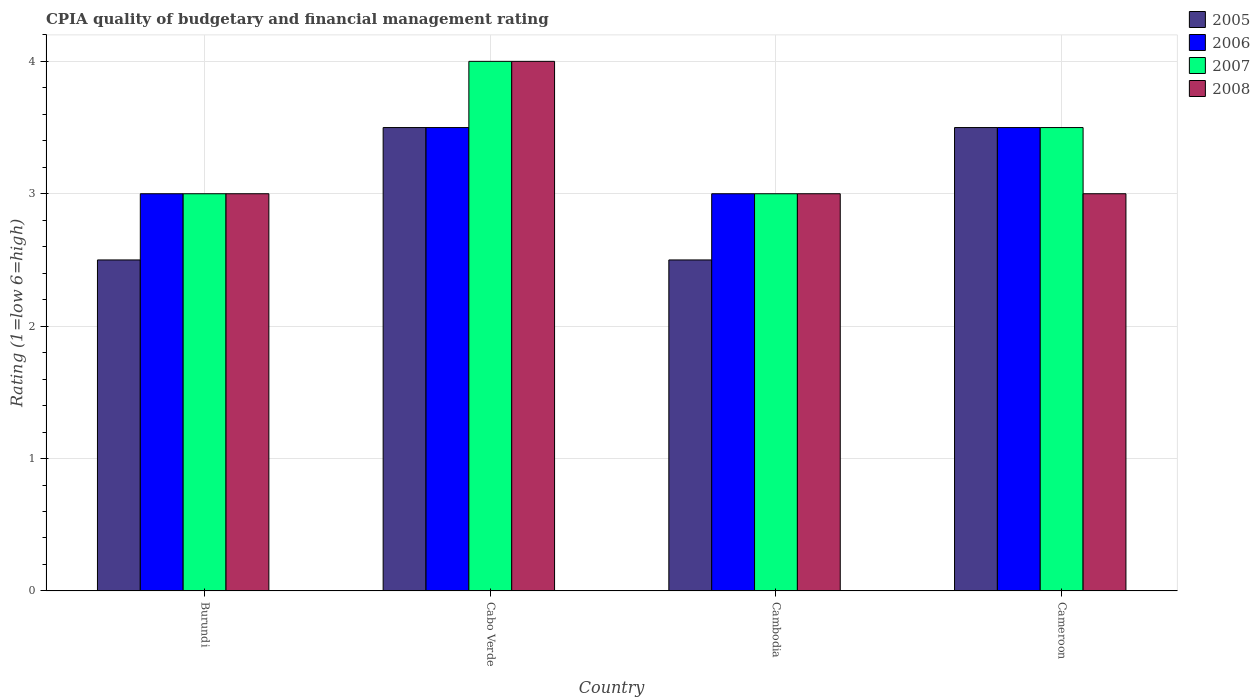How many different coloured bars are there?
Make the answer very short. 4. How many bars are there on the 1st tick from the right?
Ensure brevity in your answer.  4. What is the label of the 2nd group of bars from the left?
Offer a terse response. Cabo Verde. Across all countries, what is the minimum CPIA rating in 2008?
Provide a succinct answer. 3. In which country was the CPIA rating in 2008 maximum?
Keep it short and to the point. Cabo Verde. In which country was the CPIA rating in 2008 minimum?
Keep it short and to the point. Burundi. What is the difference between the CPIA rating in 2007 in Cabo Verde and that in Cameroon?
Your response must be concise. 0.5. What is the difference between the CPIA rating of/in 2006 and CPIA rating of/in 2008 in Cambodia?
Keep it short and to the point. 0. What is the ratio of the CPIA rating in 2006 in Cambodia to that in Cameroon?
Offer a terse response. 0.86. What is the difference between the highest and the second highest CPIA rating in 2005?
Make the answer very short. -1. Is it the case that in every country, the sum of the CPIA rating in 2008 and CPIA rating in 2007 is greater than the sum of CPIA rating in 2006 and CPIA rating in 2005?
Keep it short and to the point. No. Is it the case that in every country, the sum of the CPIA rating in 2007 and CPIA rating in 2006 is greater than the CPIA rating in 2008?
Keep it short and to the point. Yes. How many bars are there?
Your response must be concise. 16. Are all the bars in the graph horizontal?
Your answer should be very brief. No. How many countries are there in the graph?
Provide a short and direct response. 4. What is the difference between two consecutive major ticks on the Y-axis?
Your answer should be compact. 1. Does the graph contain grids?
Make the answer very short. Yes. How many legend labels are there?
Your response must be concise. 4. How are the legend labels stacked?
Make the answer very short. Vertical. What is the title of the graph?
Your response must be concise. CPIA quality of budgetary and financial management rating. What is the Rating (1=low 6=high) of 2006 in Burundi?
Offer a very short reply. 3. What is the Rating (1=low 6=high) of 2005 in Cabo Verde?
Your answer should be compact. 3.5. What is the Rating (1=low 6=high) in 2006 in Cabo Verde?
Make the answer very short. 3.5. What is the Rating (1=low 6=high) in 2008 in Cabo Verde?
Offer a terse response. 4. What is the Rating (1=low 6=high) of 2006 in Cambodia?
Provide a short and direct response. 3. What is the Rating (1=low 6=high) in 2006 in Cameroon?
Provide a succinct answer. 3.5. What is the Rating (1=low 6=high) of 2007 in Cameroon?
Your answer should be compact. 3.5. What is the Rating (1=low 6=high) in 2008 in Cameroon?
Your answer should be very brief. 3. Across all countries, what is the maximum Rating (1=low 6=high) in 2006?
Give a very brief answer. 3.5. Across all countries, what is the maximum Rating (1=low 6=high) of 2007?
Give a very brief answer. 4. Across all countries, what is the maximum Rating (1=low 6=high) in 2008?
Provide a succinct answer. 4. Across all countries, what is the minimum Rating (1=low 6=high) in 2005?
Keep it short and to the point. 2.5. Across all countries, what is the minimum Rating (1=low 6=high) of 2007?
Provide a succinct answer. 3. Across all countries, what is the minimum Rating (1=low 6=high) of 2008?
Give a very brief answer. 3. What is the total Rating (1=low 6=high) in 2005 in the graph?
Your response must be concise. 12. What is the total Rating (1=low 6=high) of 2008 in the graph?
Your answer should be compact. 13. What is the difference between the Rating (1=low 6=high) of 2005 in Burundi and that in Cabo Verde?
Provide a short and direct response. -1. What is the difference between the Rating (1=low 6=high) in 2006 in Burundi and that in Cabo Verde?
Your answer should be very brief. -0.5. What is the difference between the Rating (1=low 6=high) of 2006 in Burundi and that in Cambodia?
Provide a succinct answer. 0. What is the difference between the Rating (1=low 6=high) of 2007 in Burundi and that in Cambodia?
Your answer should be compact. 0. What is the difference between the Rating (1=low 6=high) in 2005 in Burundi and that in Cameroon?
Your response must be concise. -1. What is the difference between the Rating (1=low 6=high) of 2006 in Burundi and that in Cameroon?
Your answer should be very brief. -0.5. What is the difference between the Rating (1=low 6=high) of 2008 in Burundi and that in Cameroon?
Your answer should be very brief. 0. What is the difference between the Rating (1=low 6=high) in 2007 in Cabo Verde and that in Cambodia?
Give a very brief answer. 1. What is the difference between the Rating (1=low 6=high) in 2008 in Cabo Verde and that in Cambodia?
Keep it short and to the point. 1. What is the difference between the Rating (1=low 6=high) of 2007 in Cabo Verde and that in Cameroon?
Offer a very short reply. 0.5. What is the difference between the Rating (1=low 6=high) in 2008 in Cabo Verde and that in Cameroon?
Your answer should be compact. 1. What is the difference between the Rating (1=low 6=high) in 2005 in Cambodia and that in Cameroon?
Your response must be concise. -1. What is the difference between the Rating (1=low 6=high) in 2006 in Cambodia and that in Cameroon?
Give a very brief answer. -0.5. What is the difference between the Rating (1=low 6=high) in 2008 in Cambodia and that in Cameroon?
Your response must be concise. 0. What is the difference between the Rating (1=low 6=high) of 2005 in Burundi and the Rating (1=low 6=high) of 2008 in Cabo Verde?
Provide a succinct answer. -1.5. What is the difference between the Rating (1=low 6=high) in 2007 in Burundi and the Rating (1=low 6=high) in 2008 in Cabo Verde?
Keep it short and to the point. -1. What is the difference between the Rating (1=low 6=high) of 2005 in Burundi and the Rating (1=low 6=high) of 2008 in Cambodia?
Your response must be concise. -0.5. What is the difference between the Rating (1=low 6=high) in 2006 in Burundi and the Rating (1=low 6=high) in 2007 in Cambodia?
Make the answer very short. 0. What is the difference between the Rating (1=low 6=high) of 2007 in Burundi and the Rating (1=low 6=high) of 2008 in Cambodia?
Your answer should be compact. 0. What is the difference between the Rating (1=low 6=high) of 2005 in Burundi and the Rating (1=low 6=high) of 2006 in Cameroon?
Keep it short and to the point. -1. What is the difference between the Rating (1=low 6=high) in 2005 in Burundi and the Rating (1=low 6=high) in 2008 in Cameroon?
Keep it short and to the point. -0.5. What is the difference between the Rating (1=low 6=high) of 2006 in Burundi and the Rating (1=low 6=high) of 2007 in Cameroon?
Provide a succinct answer. -0.5. What is the difference between the Rating (1=low 6=high) in 2006 in Cabo Verde and the Rating (1=low 6=high) in 2007 in Cambodia?
Make the answer very short. 0.5. What is the difference between the Rating (1=low 6=high) in 2005 in Cabo Verde and the Rating (1=low 6=high) in 2006 in Cameroon?
Offer a terse response. 0. What is the difference between the Rating (1=low 6=high) of 2005 in Cabo Verde and the Rating (1=low 6=high) of 2008 in Cameroon?
Offer a very short reply. 0.5. What is the difference between the Rating (1=low 6=high) in 2006 in Cabo Verde and the Rating (1=low 6=high) in 2007 in Cameroon?
Give a very brief answer. 0. What is the difference between the Rating (1=low 6=high) of 2006 in Cabo Verde and the Rating (1=low 6=high) of 2008 in Cameroon?
Offer a terse response. 0.5. What is the difference between the Rating (1=low 6=high) of 2005 in Cambodia and the Rating (1=low 6=high) of 2006 in Cameroon?
Give a very brief answer. -1. What is the difference between the Rating (1=low 6=high) in 2005 in Cambodia and the Rating (1=low 6=high) in 2008 in Cameroon?
Offer a terse response. -0.5. What is the difference between the Rating (1=low 6=high) in 2006 in Cambodia and the Rating (1=low 6=high) in 2007 in Cameroon?
Ensure brevity in your answer.  -0.5. What is the average Rating (1=low 6=high) in 2005 per country?
Your response must be concise. 3. What is the average Rating (1=low 6=high) in 2007 per country?
Keep it short and to the point. 3.38. What is the difference between the Rating (1=low 6=high) in 2005 and Rating (1=low 6=high) in 2006 in Burundi?
Keep it short and to the point. -0.5. What is the difference between the Rating (1=low 6=high) of 2005 and Rating (1=low 6=high) of 2007 in Burundi?
Keep it short and to the point. -0.5. What is the difference between the Rating (1=low 6=high) of 2005 and Rating (1=low 6=high) of 2008 in Burundi?
Your answer should be very brief. -0.5. What is the difference between the Rating (1=low 6=high) of 2006 and Rating (1=low 6=high) of 2007 in Burundi?
Keep it short and to the point. 0. What is the difference between the Rating (1=low 6=high) in 2006 and Rating (1=low 6=high) in 2008 in Burundi?
Provide a short and direct response. 0. What is the difference between the Rating (1=low 6=high) of 2007 and Rating (1=low 6=high) of 2008 in Burundi?
Give a very brief answer. 0. What is the difference between the Rating (1=low 6=high) in 2005 and Rating (1=low 6=high) in 2007 in Cabo Verde?
Give a very brief answer. -0.5. What is the difference between the Rating (1=low 6=high) in 2005 and Rating (1=low 6=high) in 2007 in Cambodia?
Give a very brief answer. -0.5. What is the difference between the Rating (1=low 6=high) in 2007 and Rating (1=low 6=high) in 2008 in Cambodia?
Give a very brief answer. 0. What is the difference between the Rating (1=low 6=high) of 2005 and Rating (1=low 6=high) of 2007 in Cameroon?
Your answer should be very brief. 0. What is the difference between the Rating (1=low 6=high) of 2005 and Rating (1=low 6=high) of 2008 in Cameroon?
Make the answer very short. 0.5. What is the difference between the Rating (1=low 6=high) of 2006 and Rating (1=low 6=high) of 2008 in Cameroon?
Offer a terse response. 0.5. What is the difference between the Rating (1=low 6=high) of 2007 and Rating (1=low 6=high) of 2008 in Cameroon?
Your answer should be very brief. 0.5. What is the ratio of the Rating (1=low 6=high) in 2008 in Burundi to that in Cabo Verde?
Provide a short and direct response. 0.75. What is the ratio of the Rating (1=low 6=high) of 2005 in Burundi to that in Cambodia?
Your response must be concise. 1. What is the ratio of the Rating (1=low 6=high) of 2006 in Burundi to that in Cambodia?
Offer a terse response. 1. What is the ratio of the Rating (1=low 6=high) in 2005 in Burundi to that in Cameroon?
Ensure brevity in your answer.  0.71. What is the ratio of the Rating (1=low 6=high) of 2005 in Cabo Verde to that in Cambodia?
Offer a terse response. 1.4. What is the ratio of the Rating (1=low 6=high) in 2008 in Cabo Verde to that in Cambodia?
Keep it short and to the point. 1.33. What is the ratio of the Rating (1=low 6=high) in 2007 in Cabo Verde to that in Cameroon?
Offer a very short reply. 1.14. What is the ratio of the Rating (1=low 6=high) in 2008 in Cabo Verde to that in Cameroon?
Offer a terse response. 1.33. What is the ratio of the Rating (1=low 6=high) of 2007 in Cambodia to that in Cameroon?
Offer a terse response. 0.86. What is the difference between the highest and the second highest Rating (1=low 6=high) of 2007?
Offer a terse response. 0.5. What is the difference between the highest and the lowest Rating (1=low 6=high) of 2005?
Provide a short and direct response. 1. What is the difference between the highest and the lowest Rating (1=low 6=high) of 2006?
Keep it short and to the point. 0.5. What is the difference between the highest and the lowest Rating (1=low 6=high) of 2007?
Give a very brief answer. 1. What is the difference between the highest and the lowest Rating (1=low 6=high) in 2008?
Your answer should be very brief. 1. 